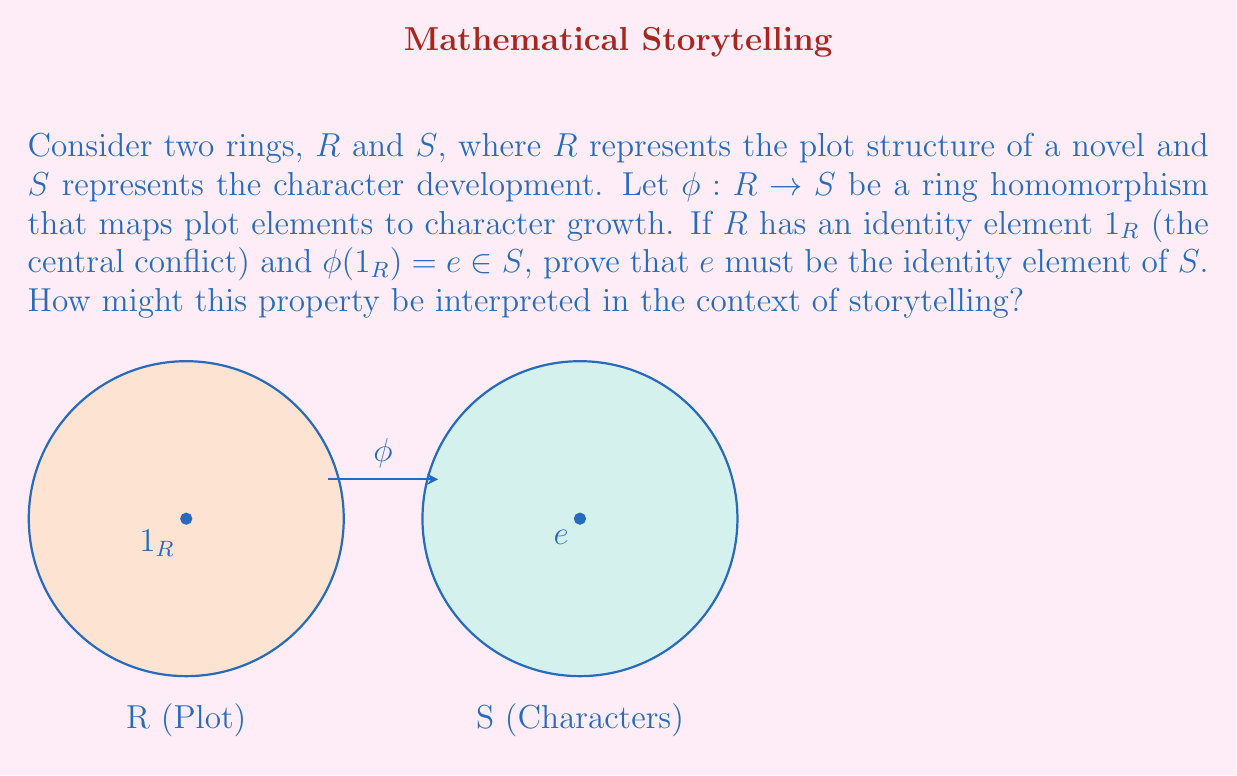Help me with this question. To prove this property and interpret it in storytelling, let's follow these steps:

1) First, recall the definition of a ring homomorphism. For any $a, b \in R$:
   $$\phi(a + b) = \phi(a) + \phi(b)$$
   $$\phi(ab) = \phi(a)\phi(b)$$

2) Now, let's consider any element $s \in S$. We can write:
   $$\phi(1_R)s = es$$

3) Using the homomorphism property:
   $$\phi(1_R)s = \phi(1_R \cdot 1_R)s = \phi(1_R)\phi(1_R)s = e(es) = (ee)s$$

4) Therefore:
   $$es = (ee)s$$

5) Since this holds for all $s \in S$, we can conclude:
   $$e = ee$$

6) Now, for any $s \in S$:
   $$es = s$$

7) This proves that $e$ is the identity element of $S$.

Interpretation in storytelling:
This property suggests that the central conflict of the plot (represented by $1_R$) maps to the core essence of character development (represented by $e$). Just as $e$ interacts with all elements in $S$ without changing them, the central conflict influences all aspects of character growth without altering their fundamental nature. This mirrors how a well-crafted story's central conflict should drive character development throughout the narrative.
Answer: $e$ is the identity element of $S$, representing the core essence of character development driven by the central conflict. 